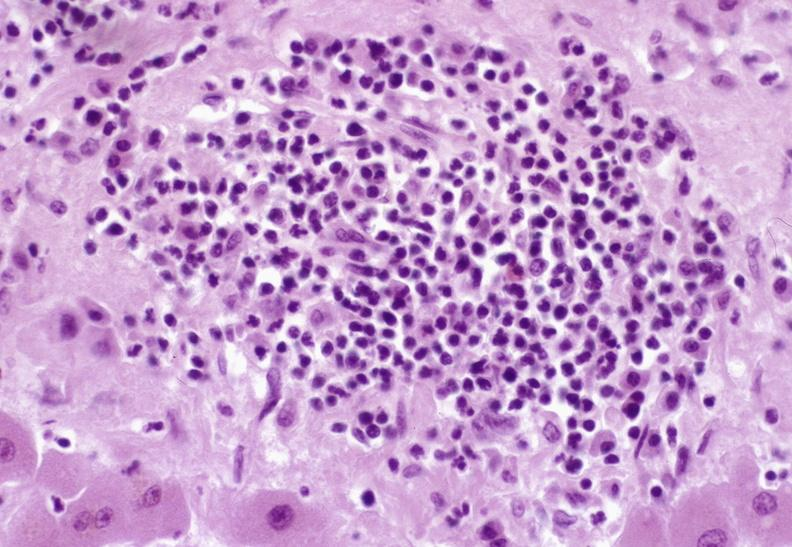s hepatobiliary present?
Answer the question using a single word or phrase. Yes 